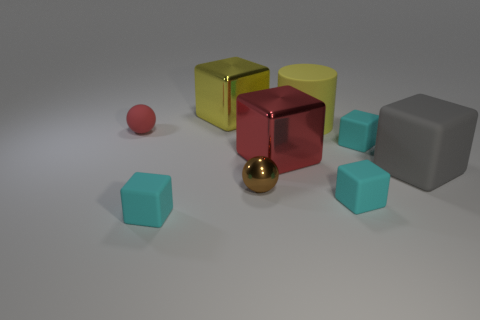Subtract all large red cubes. How many cubes are left? 5 Subtract all brown spheres. How many spheres are left? 1 Subtract all spheres. How many objects are left? 7 Subtract 1 balls. How many balls are left? 1 Subtract all brown cubes. Subtract all green balls. How many cubes are left? 6 Subtract all cyan blocks. How many brown spheres are left? 1 Subtract all big yellow cubes. Subtract all red shiny things. How many objects are left? 7 Add 3 gray matte objects. How many gray matte objects are left? 4 Add 9 big red cubes. How many big red cubes exist? 10 Subtract 1 yellow cylinders. How many objects are left? 8 